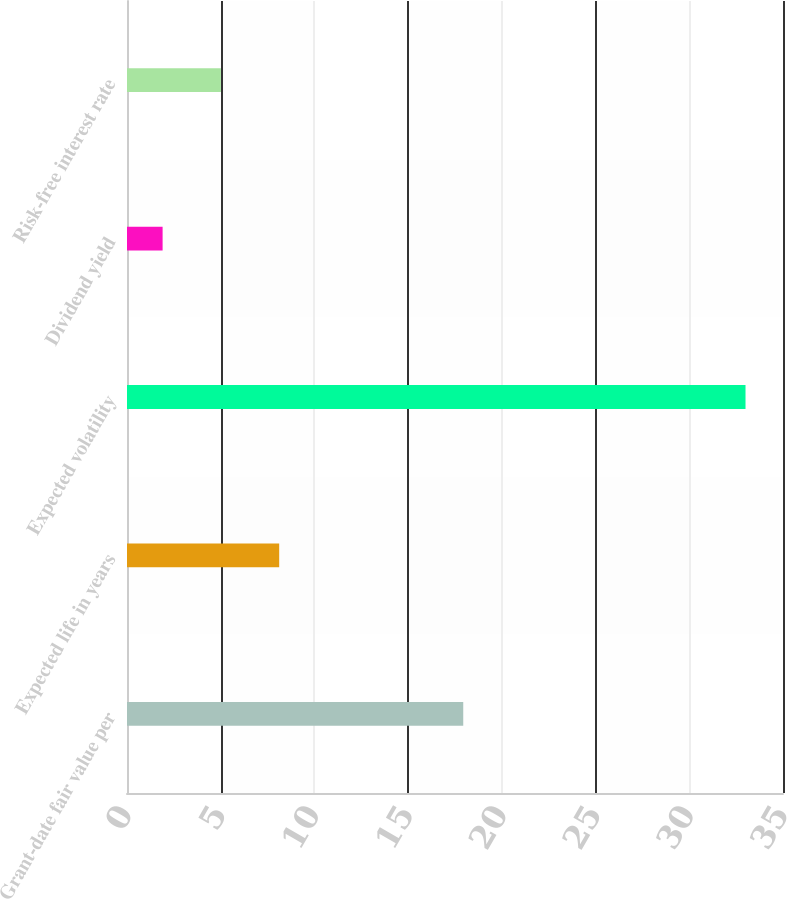Convert chart to OTSL. <chart><loc_0><loc_0><loc_500><loc_500><bar_chart><fcel>Grant-date fair value per<fcel>Expected life in years<fcel>Expected volatility<fcel>Dividend yield<fcel>Risk-free interest rate<nl><fcel>17.94<fcel>8.12<fcel>33<fcel>1.9<fcel>5.01<nl></chart> 